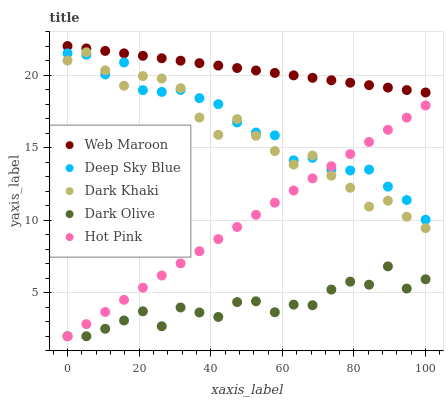Does Dark Olive have the minimum area under the curve?
Answer yes or no. Yes. Does Web Maroon have the maximum area under the curve?
Answer yes or no. Yes. Does Web Maroon have the minimum area under the curve?
Answer yes or no. No. Does Dark Olive have the maximum area under the curve?
Answer yes or no. No. Is Web Maroon the smoothest?
Answer yes or no. Yes. Is Dark Olive the roughest?
Answer yes or no. Yes. Is Dark Olive the smoothest?
Answer yes or no. No. Is Web Maroon the roughest?
Answer yes or no. No. Does Dark Olive have the lowest value?
Answer yes or no. Yes. Does Web Maroon have the lowest value?
Answer yes or no. No. Does Web Maroon have the highest value?
Answer yes or no. Yes. Does Dark Olive have the highest value?
Answer yes or no. No. Is Dark Olive less than Web Maroon?
Answer yes or no. Yes. Is Deep Sky Blue greater than Dark Olive?
Answer yes or no. Yes. Does Hot Pink intersect Dark Khaki?
Answer yes or no. Yes. Is Hot Pink less than Dark Khaki?
Answer yes or no. No. Is Hot Pink greater than Dark Khaki?
Answer yes or no. No. Does Dark Olive intersect Web Maroon?
Answer yes or no. No. 